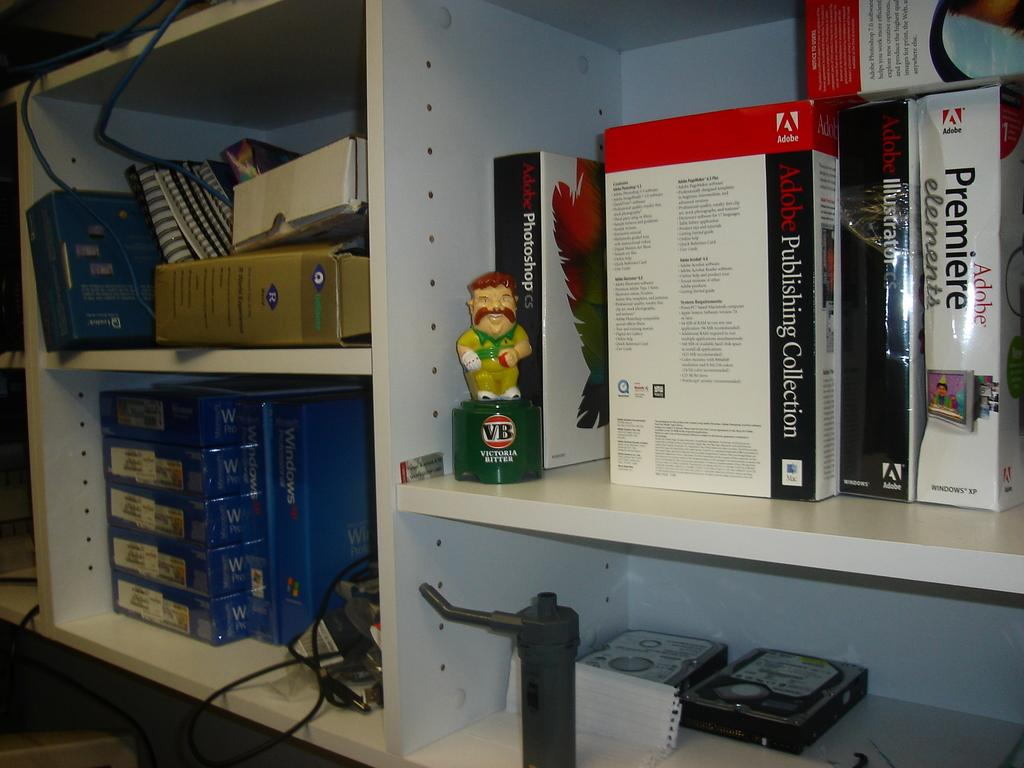<image>
Offer a succinct explanation of the picture presented. A storage shelf has sofware cases on it including Adobe Publishing Collection and Adobe Premiere Elements. 